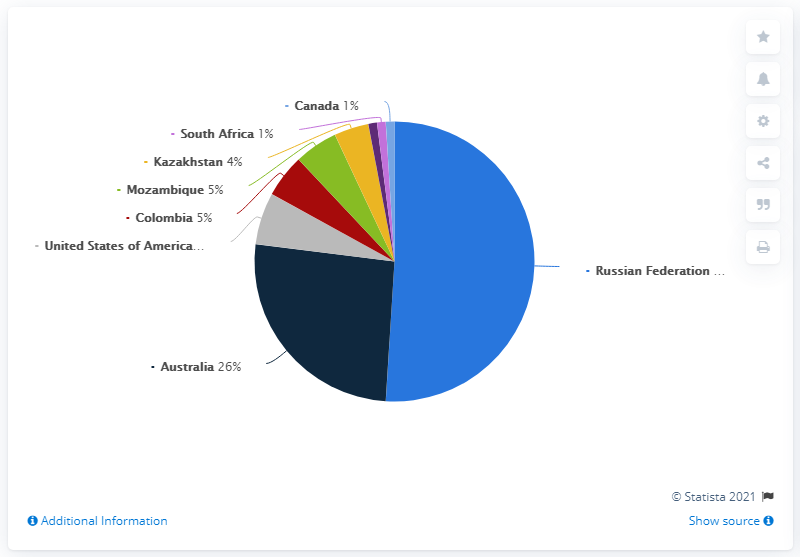Specify some key components in this picture. The ratio of Kazakhstan to Mozambique is 0.8. Nine countries have been considered in total. 